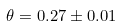<formula> <loc_0><loc_0><loc_500><loc_500>\theta = 0 . 2 7 \pm 0 . 0 1</formula> 